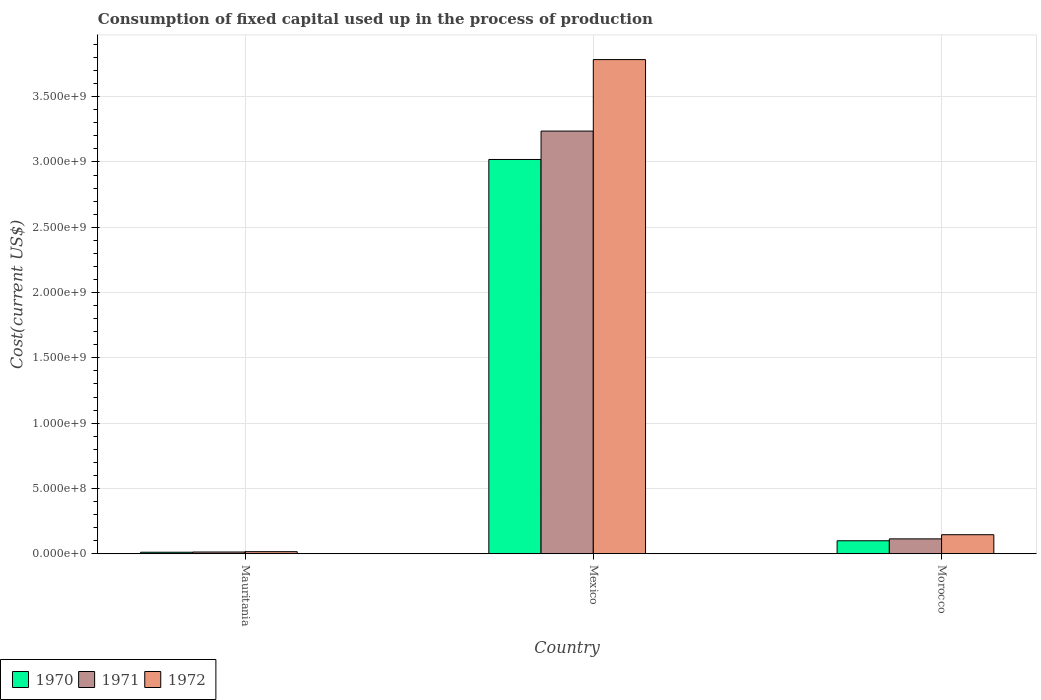How many groups of bars are there?
Offer a very short reply. 3. Are the number of bars on each tick of the X-axis equal?
Keep it short and to the point. Yes. How many bars are there on the 3rd tick from the right?
Provide a succinct answer. 3. What is the label of the 1st group of bars from the left?
Offer a terse response. Mauritania. In how many cases, is the number of bars for a given country not equal to the number of legend labels?
Your answer should be compact. 0. What is the amount consumed in the process of production in 1971 in Mauritania?
Your response must be concise. 1.33e+07. Across all countries, what is the maximum amount consumed in the process of production in 1972?
Provide a short and direct response. 3.78e+09. Across all countries, what is the minimum amount consumed in the process of production in 1972?
Provide a short and direct response. 1.58e+07. In which country was the amount consumed in the process of production in 1971 minimum?
Offer a terse response. Mauritania. What is the total amount consumed in the process of production in 1971 in the graph?
Your response must be concise. 3.36e+09. What is the difference between the amount consumed in the process of production in 1970 in Mexico and that in Morocco?
Your response must be concise. 2.92e+09. What is the difference between the amount consumed in the process of production in 1970 in Mauritania and the amount consumed in the process of production in 1971 in Mexico?
Your answer should be very brief. -3.22e+09. What is the average amount consumed in the process of production in 1972 per country?
Ensure brevity in your answer.  1.32e+09. What is the difference between the amount consumed in the process of production of/in 1970 and amount consumed in the process of production of/in 1972 in Mauritania?
Provide a succinct answer. -4.37e+06. In how many countries, is the amount consumed in the process of production in 1970 greater than 3400000000 US$?
Offer a very short reply. 0. What is the ratio of the amount consumed in the process of production in 1971 in Mauritania to that in Mexico?
Keep it short and to the point. 0. Is the difference between the amount consumed in the process of production in 1970 in Mauritania and Morocco greater than the difference between the amount consumed in the process of production in 1972 in Mauritania and Morocco?
Your answer should be very brief. Yes. What is the difference between the highest and the second highest amount consumed in the process of production in 1972?
Your response must be concise. 3.77e+09. What is the difference between the highest and the lowest amount consumed in the process of production in 1970?
Make the answer very short. 3.01e+09. In how many countries, is the amount consumed in the process of production in 1971 greater than the average amount consumed in the process of production in 1971 taken over all countries?
Ensure brevity in your answer.  1. Is the sum of the amount consumed in the process of production in 1971 in Mauritania and Mexico greater than the maximum amount consumed in the process of production in 1972 across all countries?
Give a very brief answer. No. What does the 1st bar from the left in Morocco represents?
Your response must be concise. 1970. What does the 2nd bar from the right in Mexico represents?
Offer a very short reply. 1971. Does the graph contain any zero values?
Ensure brevity in your answer.  No. Does the graph contain grids?
Your answer should be very brief. Yes. How many legend labels are there?
Keep it short and to the point. 3. How are the legend labels stacked?
Your answer should be compact. Horizontal. What is the title of the graph?
Your answer should be very brief. Consumption of fixed capital used up in the process of production. What is the label or title of the Y-axis?
Keep it short and to the point. Cost(current US$). What is the Cost(current US$) in 1970 in Mauritania?
Provide a succinct answer. 1.15e+07. What is the Cost(current US$) in 1971 in Mauritania?
Ensure brevity in your answer.  1.33e+07. What is the Cost(current US$) of 1972 in Mauritania?
Give a very brief answer. 1.58e+07. What is the Cost(current US$) of 1970 in Mexico?
Provide a succinct answer. 3.02e+09. What is the Cost(current US$) of 1971 in Mexico?
Offer a terse response. 3.24e+09. What is the Cost(current US$) of 1972 in Mexico?
Give a very brief answer. 3.78e+09. What is the Cost(current US$) of 1970 in Morocco?
Ensure brevity in your answer.  9.95e+07. What is the Cost(current US$) in 1971 in Morocco?
Offer a very short reply. 1.14e+08. What is the Cost(current US$) in 1972 in Morocco?
Provide a short and direct response. 1.46e+08. Across all countries, what is the maximum Cost(current US$) in 1970?
Keep it short and to the point. 3.02e+09. Across all countries, what is the maximum Cost(current US$) in 1971?
Ensure brevity in your answer.  3.24e+09. Across all countries, what is the maximum Cost(current US$) of 1972?
Provide a short and direct response. 3.78e+09. Across all countries, what is the minimum Cost(current US$) of 1970?
Ensure brevity in your answer.  1.15e+07. Across all countries, what is the minimum Cost(current US$) in 1971?
Offer a terse response. 1.33e+07. Across all countries, what is the minimum Cost(current US$) of 1972?
Provide a short and direct response. 1.58e+07. What is the total Cost(current US$) of 1970 in the graph?
Offer a terse response. 3.13e+09. What is the total Cost(current US$) in 1971 in the graph?
Give a very brief answer. 3.36e+09. What is the total Cost(current US$) in 1972 in the graph?
Offer a very short reply. 3.95e+09. What is the difference between the Cost(current US$) in 1970 in Mauritania and that in Mexico?
Your response must be concise. -3.01e+09. What is the difference between the Cost(current US$) in 1971 in Mauritania and that in Mexico?
Ensure brevity in your answer.  -3.22e+09. What is the difference between the Cost(current US$) of 1972 in Mauritania and that in Mexico?
Ensure brevity in your answer.  -3.77e+09. What is the difference between the Cost(current US$) of 1970 in Mauritania and that in Morocco?
Make the answer very short. -8.80e+07. What is the difference between the Cost(current US$) in 1971 in Mauritania and that in Morocco?
Offer a terse response. -1.01e+08. What is the difference between the Cost(current US$) of 1972 in Mauritania and that in Morocco?
Ensure brevity in your answer.  -1.30e+08. What is the difference between the Cost(current US$) of 1970 in Mexico and that in Morocco?
Give a very brief answer. 2.92e+09. What is the difference between the Cost(current US$) of 1971 in Mexico and that in Morocco?
Give a very brief answer. 3.12e+09. What is the difference between the Cost(current US$) in 1972 in Mexico and that in Morocco?
Offer a very short reply. 3.64e+09. What is the difference between the Cost(current US$) of 1970 in Mauritania and the Cost(current US$) of 1971 in Mexico?
Keep it short and to the point. -3.22e+09. What is the difference between the Cost(current US$) of 1970 in Mauritania and the Cost(current US$) of 1972 in Mexico?
Your answer should be very brief. -3.77e+09. What is the difference between the Cost(current US$) of 1971 in Mauritania and the Cost(current US$) of 1972 in Mexico?
Make the answer very short. -3.77e+09. What is the difference between the Cost(current US$) of 1970 in Mauritania and the Cost(current US$) of 1971 in Morocco?
Ensure brevity in your answer.  -1.02e+08. What is the difference between the Cost(current US$) of 1970 in Mauritania and the Cost(current US$) of 1972 in Morocco?
Make the answer very short. -1.34e+08. What is the difference between the Cost(current US$) in 1971 in Mauritania and the Cost(current US$) in 1972 in Morocco?
Your answer should be very brief. -1.33e+08. What is the difference between the Cost(current US$) of 1970 in Mexico and the Cost(current US$) of 1971 in Morocco?
Ensure brevity in your answer.  2.91e+09. What is the difference between the Cost(current US$) of 1970 in Mexico and the Cost(current US$) of 1972 in Morocco?
Provide a short and direct response. 2.87e+09. What is the difference between the Cost(current US$) in 1971 in Mexico and the Cost(current US$) in 1972 in Morocco?
Provide a short and direct response. 3.09e+09. What is the average Cost(current US$) of 1970 per country?
Your answer should be very brief. 1.04e+09. What is the average Cost(current US$) in 1971 per country?
Give a very brief answer. 1.12e+09. What is the average Cost(current US$) of 1972 per country?
Your answer should be very brief. 1.32e+09. What is the difference between the Cost(current US$) in 1970 and Cost(current US$) in 1971 in Mauritania?
Offer a very short reply. -1.80e+06. What is the difference between the Cost(current US$) in 1970 and Cost(current US$) in 1972 in Mauritania?
Your response must be concise. -4.37e+06. What is the difference between the Cost(current US$) in 1971 and Cost(current US$) in 1972 in Mauritania?
Provide a short and direct response. -2.57e+06. What is the difference between the Cost(current US$) of 1970 and Cost(current US$) of 1971 in Mexico?
Your answer should be compact. -2.17e+08. What is the difference between the Cost(current US$) in 1970 and Cost(current US$) in 1972 in Mexico?
Provide a succinct answer. -7.65e+08. What is the difference between the Cost(current US$) of 1971 and Cost(current US$) of 1972 in Mexico?
Keep it short and to the point. -5.48e+08. What is the difference between the Cost(current US$) of 1970 and Cost(current US$) of 1971 in Morocco?
Offer a terse response. -1.44e+07. What is the difference between the Cost(current US$) in 1970 and Cost(current US$) in 1972 in Morocco?
Make the answer very short. -4.63e+07. What is the difference between the Cost(current US$) of 1971 and Cost(current US$) of 1972 in Morocco?
Your answer should be compact. -3.18e+07. What is the ratio of the Cost(current US$) of 1970 in Mauritania to that in Mexico?
Your answer should be compact. 0. What is the ratio of the Cost(current US$) of 1971 in Mauritania to that in Mexico?
Give a very brief answer. 0. What is the ratio of the Cost(current US$) in 1972 in Mauritania to that in Mexico?
Offer a very short reply. 0. What is the ratio of the Cost(current US$) of 1970 in Mauritania to that in Morocco?
Provide a succinct answer. 0.12. What is the ratio of the Cost(current US$) of 1971 in Mauritania to that in Morocco?
Keep it short and to the point. 0.12. What is the ratio of the Cost(current US$) of 1972 in Mauritania to that in Morocco?
Your response must be concise. 0.11. What is the ratio of the Cost(current US$) of 1970 in Mexico to that in Morocco?
Make the answer very short. 30.34. What is the ratio of the Cost(current US$) in 1971 in Mexico to that in Morocco?
Your answer should be compact. 28.41. What is the ratio of the Cost(current US$) of 1972 in Mexico to that in Morocco?
Keep it short and to the point. 25.96. What is the difference between the highest and the second highest Cost(current US$) of 1970?
Your answer should be very brief. 2.92e+09. What is the difference between the highest and the second highest Cost(current US$) of 1971?
Offer a very short reply. 3.12e+09. What is the difference between the highest and the second highest Cost(current US$) in 1972?
Make the answer very short. 3.64e+09. What is the difference between the highest and the lowest Cost(current US$) in 1970?
Make the answer very short. 3.01e+09. What is the difference between the highest and the lowest Cost(current US$) in 1971?
Your answer should be very brief. 3.22e+09. What is the difference between the highest and the lowest Cost(current US$) of 1972?
Your response must be concise. 3.77e+09. 